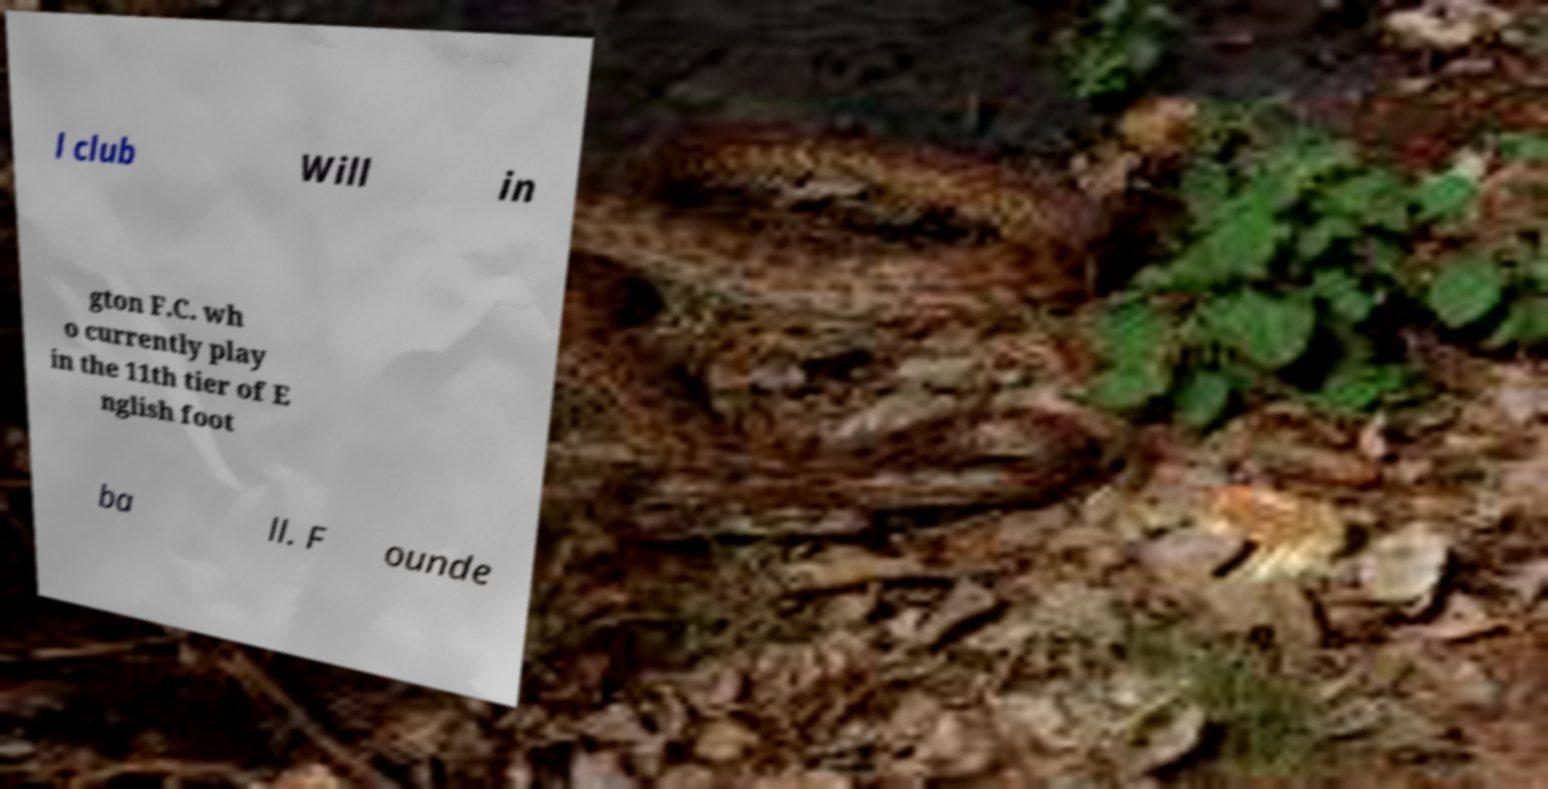Can you accurately transcribe the text from the provided image for me? l club Will in gton F.C. wh o currently play in the 11th tier of E nglish foot ba ll. F ounde 